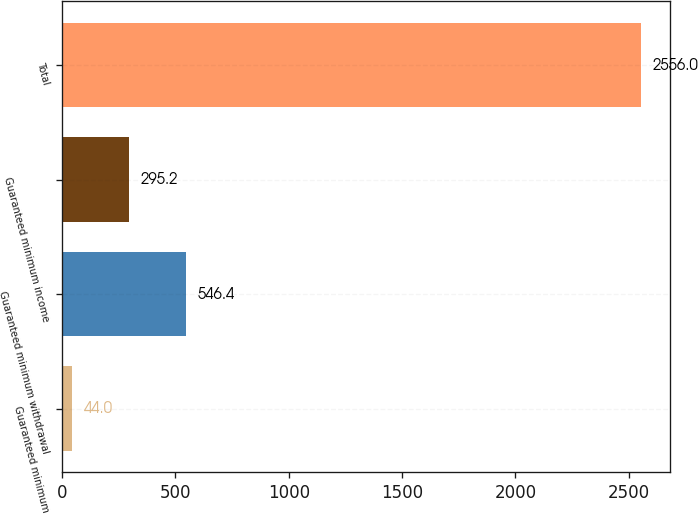Convert chart. <chart><loc_0><loc_0><loc_500><loc_500><bar_chart><fcel>Guaranteed minimum<fcel>Guaranteed minimum withdrawal<fcel>Guaranteed minimum income<fcel>Total<nl><fcel>44<fcel>546.4<fcel>295.2<fcel>2556<nl></chart> 